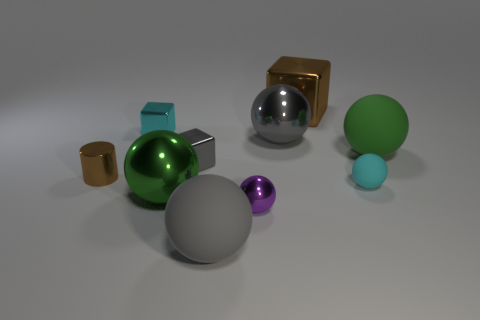How many tiny objects are cubes or green rubber spheres?
Provide a succinct answer. 2. How big is the green matte ball?
Your answer should be compact. Large. Are there more small rubber objects that are in front of the tiny cyan shiny object than purple matte spheres?
Give a very brief answer. Yes. Is the number of gray metal objects that are on the left side of the large metallic cube the same as the number of green rubber things that are behind the large gray metallic sphere?
Give a very brief answer. No. There is a ball that is to the right of the big gray metallic object and behind the brown cylinder; what color is it?
Provide a short and direct response. Green. Is there any other thing that is the same size as the purple thing?
Provide a short and direct response. Yes. Are there more small gray shiny objects left of the brown cylinder than large objects that are left of the tiny cyan cube?
Your answer should be compact. No. There is a brown object to the left of the cyan metallic cube; is it the same size as the large green metallic sphere?
Offer a very short reply. No. What number of cyan things are to the right of the small metallic block in front of the cyan object to the left of the green metal ball?
Your answer should be compact. 1. How big is the shiny block that is left of the large gray rubber object and behind the large green matte object?
Ensure brevity in your answer.  Small. 